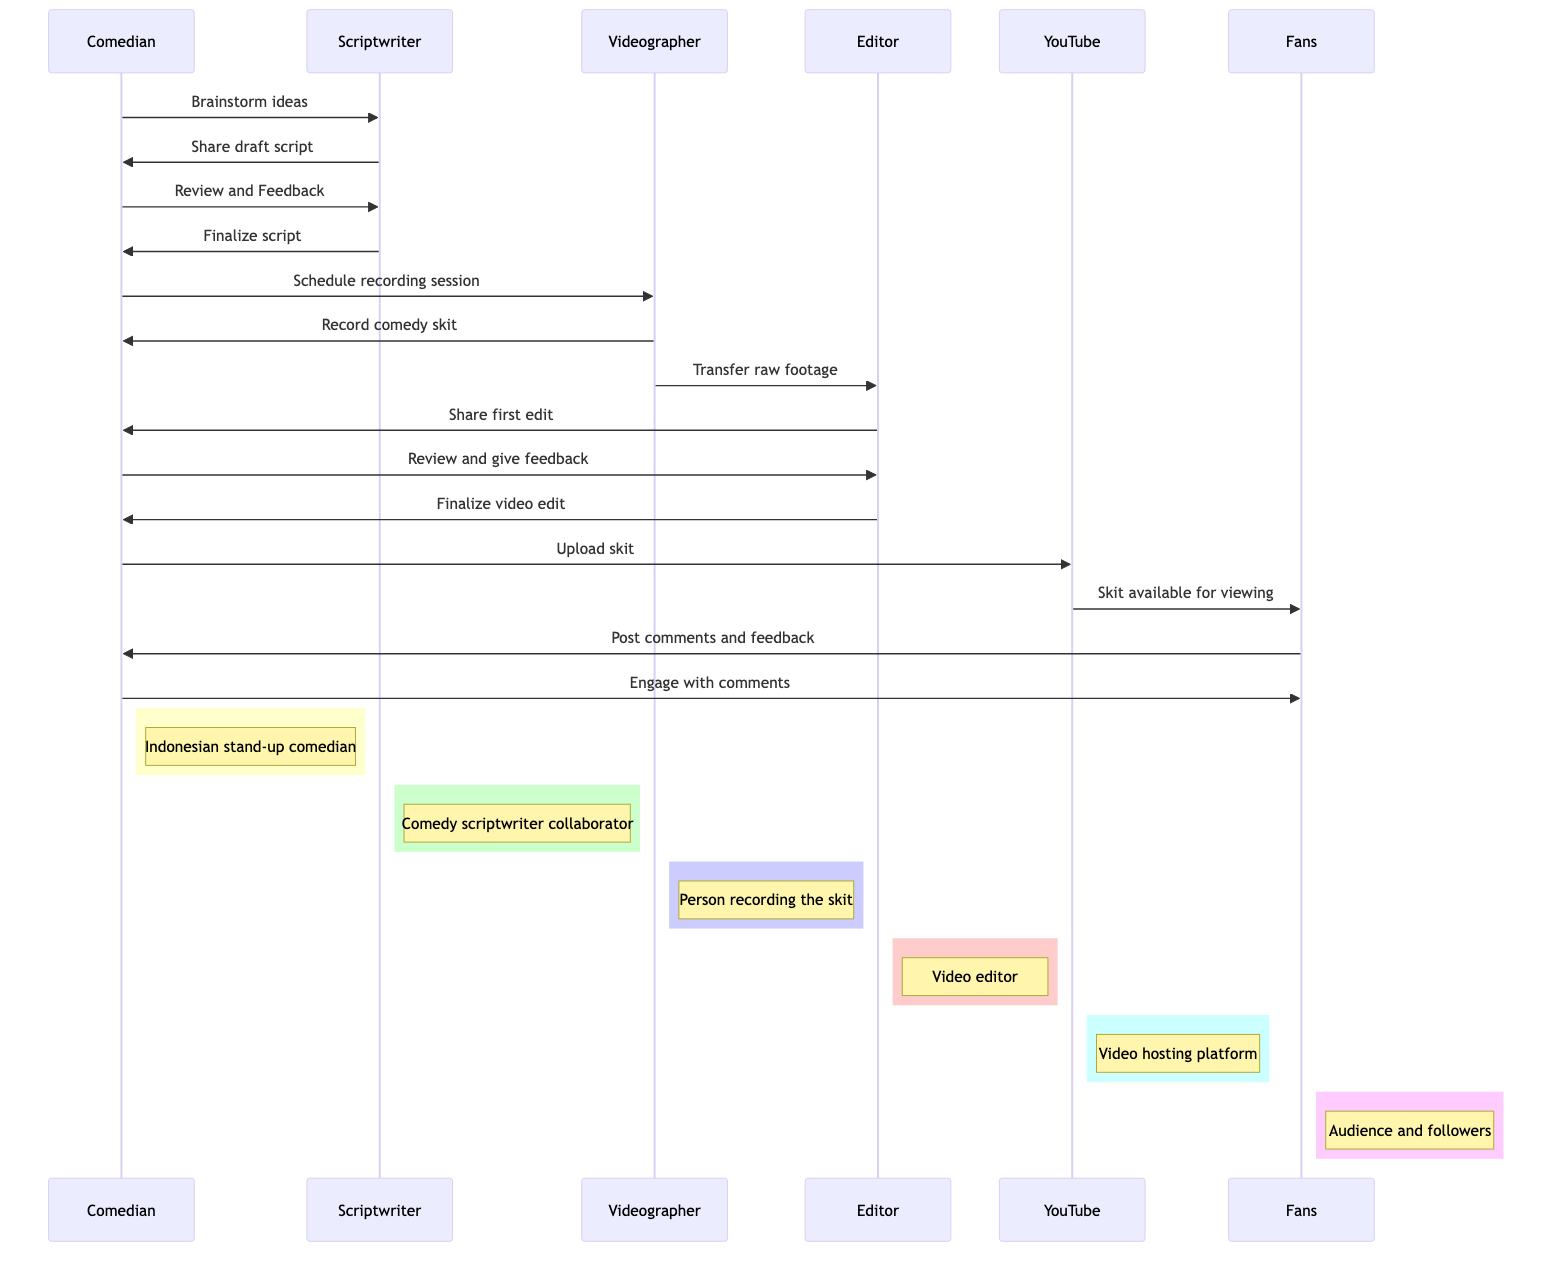What is the first message exchanged between the Comedian and the Scriptwriter? The first message in the sequence diagram is from the Comedian to the Scriptwriter, labeled "Brainstorm ideas."
Answer: Brainstorm ideas How many actors are involved in the sequence diagram? There are six actors represented in the diagram: Comedian, Scriptwriter, Videographer, Editor, YouTube, and Fans.
Answer: Six Which actor is responsible for recording the skit? The Videographer is the actor who records the skit, as indicated by the message from the Videographer to the Comedian titled "Record comedy skit."
Answer: Videographer What message does the Editor send to the Comedian after transferring raw footage? The message sent from the Editor to the Comedian after transferring raw footage is "Share first edit."
Answer: Share first edit How many steps are there between the "Finalize script" and "Upload skit"? There are three steps between "Finalize script" and "Upload skit." The steps are: scheduling recording, recording the skit, and editing the video.
Answer: Three Which actor receives comments and feedback from the Fans? The Comedian receives comments and feedback from the Fans, as shown by the message from Fans to Comedian titled "Post comments and feedback."
Answer: Comedian What is the last action depicted in the sequence diagram? The last action is the Comedian engaging with comments from the Fans, represented by the message "Engage with comments."
Answer: Engage with comments Which actor shares the final video edit before uploading to YouTube? The Editor shares the final video edit with the Comedian before it is uploaded to YouTube. This is shown in the message from Editor to Comedian labeled "Finalize video edit."
Answer: Editor What occurs immediately after the skit is uploaded to YouTube? Immediately after the skit is uploaded to YouTube, the message "Skit available for viewing" is sent to the Fans.
Answer: Skit available for viewing 